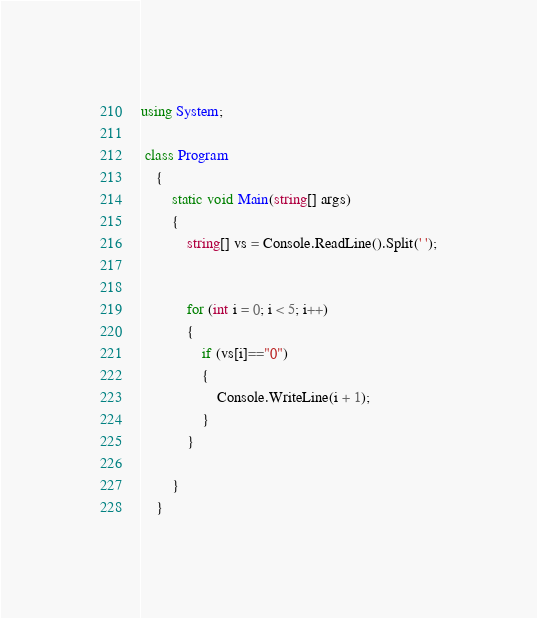<code> <loc_0><loc_0><loc_500><loc_500><_C#_>using System;

 class Program
    {
        static void Main(string[] args)
        {
            string[] vs = Console.ReadLine().Split(' ');

            
            for (int i = 0; i < 5; i++)
            {
                if (vs[i]=="0")
                {
                    Console.WriteLine(i + 1);
                }
            }

        }
    }</code> 